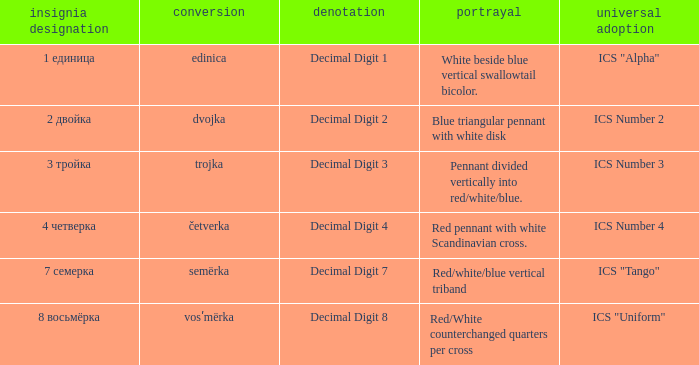What is the name of the flag that means decimal digit 2? 2 двойка. 